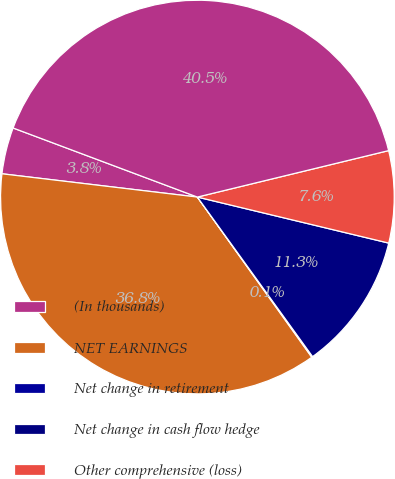Convert chart. <chart><loc_0><loc_0><loc_500><loc_500><pie_chart><fcel>(In thousands)<fcel>NET EARNINGS<fcel>Net change in retirement<fcel>Net change in cash flow hedge<fcel>Other comprehensive (loss)<fcel>TOTAL COMPREHENSIVE INCOME<nl><fcel>3.82%<fcel>36.76%<fcel>0.08%<fcel>11.29%<fcel>7.55%<fcel>40.5%<nl></chart> 